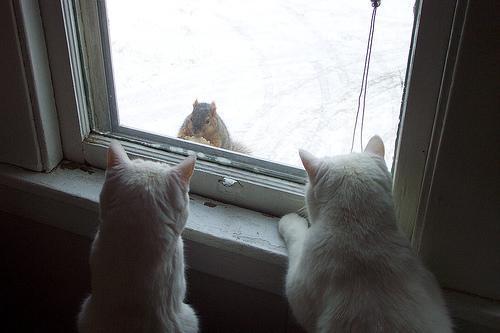How many animals are shown?
Give a very brief answer. 3. 